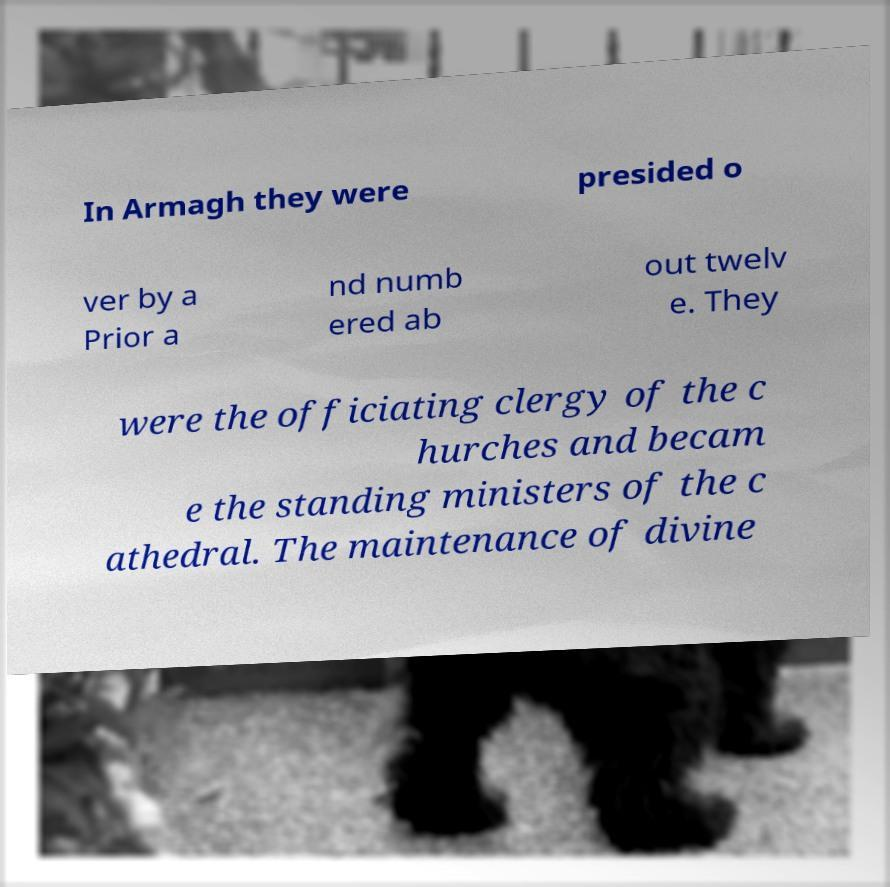What messages or text are displayed in this image? I need them in a readable, typed format. In Armagh they were presided o ver by a Prior a nd numb ered ab out twelv e. They were the officiating clergy of the c hurches and becam e the standing ministers of the c athedral. The maintenance of divine 